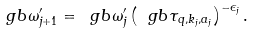<formula> <loc_0><loc_0><loc_500><loc_500>\ g b \omega ^ { \prime } _ { j + 1 } = \ g b \omega _ { j } ^ { \prime } \left ( \ g b \tau _ { q , k _ { j } , a _ { j } } \right ) ^ { - \epsilon _ { j } } .</formula> 